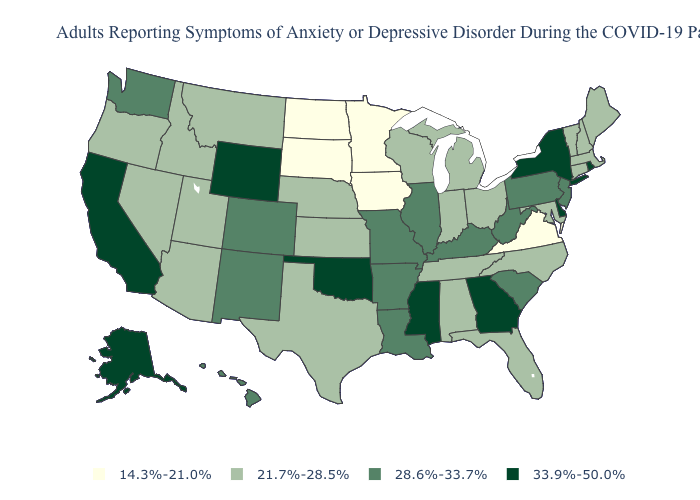What is the value of Mississippi?
Give a very brief answer. 33.9%-50.0%. What is the value of Utah?
Quick response, please. 21.7%-28.5%. Does South Dakota have the lowest value in the USA?
Give a very brief answer. Yes. Does the map have missing data?
Short answer required. No. What is the value of New Jersey?
Be succinct. 28.6%-33.7%. Which states have the highest value in the USA?
Keep it brief. Alaska, California, Delaware, Georgia, Mississippi, New York, Oklahoma, Rhode Island, Wyoming. What is the lowest value in the MidWest?
Give a very brief answer. 14.3%-21.0%. What is the lowest value in states that border Rhode Island?
Answer briefly. 21.7%-28.5%. Name the states that have a value in the range 28.6%-33.7%?
Concise answer only. Arkansas, Colorado, Hawaii, Illinois, Kentucky, Louisiana, Missouri, New Jersey, New Mexico, Pennsylvania, South Carolina, Washington, West Virginia. Name the states that have a value in the range 21.7%-28.5%?
Short answer required. Alabama, Arizona, Connecticut, Florida, Idaho, Indiana, Kansas, Maine, Maryland, Massachusetts, Michigan, Montana, Nebraska, Nevada, New Hampshire, North Carolina, Ohio, Oregon, Tennessee, Texas, Utah, Vermont, Wisconsin. What is the lowest value in the Northeast?
Write a very short answer. 21.7%-28.5%. Which states hav the highest value in the South?
Short answer required. Delaware, Georgia, Mississippi, Oklahoma. What is the value of Wyoming?
Answer briefly. 33.9%-50.0%. What is the value of Oklahoma?
Keep it brief. 33.9%-50.0%. Which states have the lowest value in the USA?
Write a very short answer. Iowa, Minnesota, North Dakota, South Dakota, Virginia. 